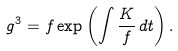<formula> <loc_0><loc_0><loc_500><loc_500>g ^ { 3 } = f \exp \left ( \int \frac { K } { f } \, d t \right ) .</formula> 